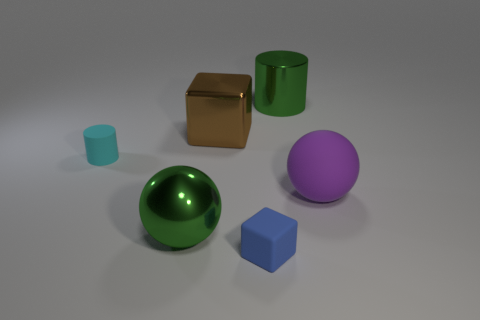There is a rubber sphere that is the same size as the brown metal cube; what color is it?
Offer a very short reply. Purple. There is a big green object that is left of the green object to the right of the small rubber thing that is in front of the cyan object; what is its shape?
Provide a short and direct response. Sphere. What is the shape of the big object that is the same color as the metallic sphere?
Give a very brief answer. Cylinder. How many things are large red cubes or green objects that are behind the large shiny ball?
Offer a very short reply. 1. Do the cube that is behind the green shiny sphere and the large green cylinder have the same size?
Make the answer very short. Yes. What is the cube behind the rubber cube made of?
Offer a very short reply. Metal. Is the number of small cylinders that are to the right of the blue cube the same as the number of blue cubes behind the large green metallic cylinder?
Your response must be concise. Yes. There is another thing that is the same shape as the cyan thing; what color is it?
Your answer should be compact. Green. Is there anything else that is the same color as the tiny matte cube?
Offer a very short reply. No. How many metallic things are either small blue blocks or big green objects?
Keep it short and to the point. 2. 